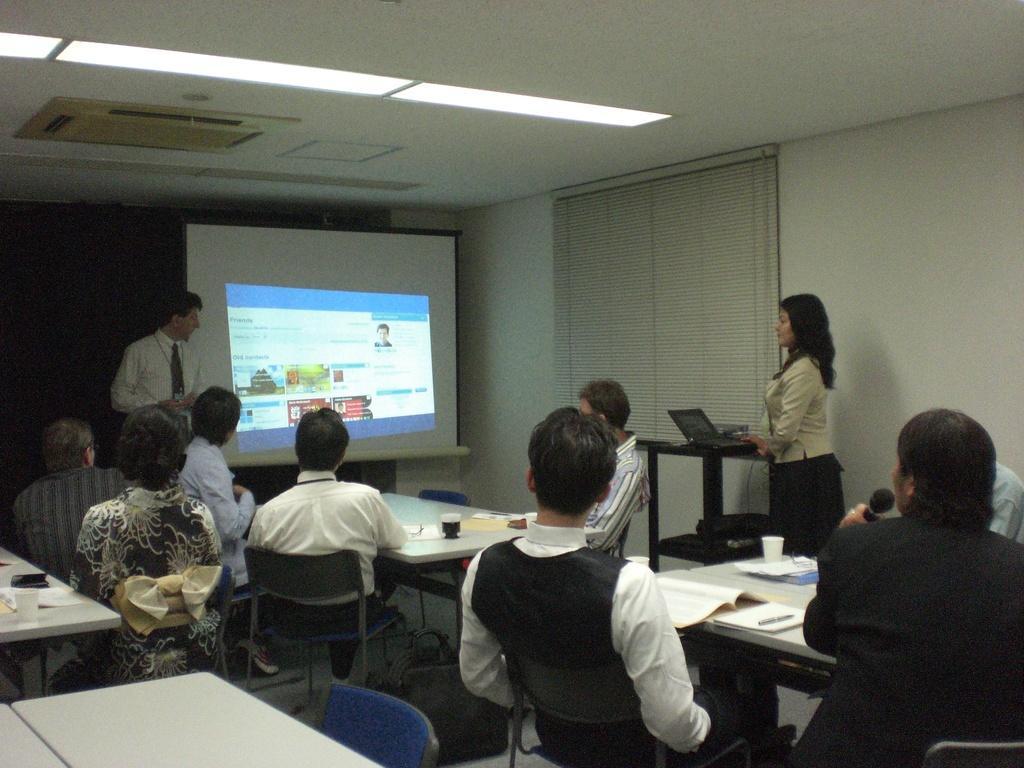Describe this image in one or two sentences. In this picture we can see some persons are sitting on the chairs. These are the tables. On the table there are books, and a cup. Here we can see two persons standing on the floor. This is laptop. Here we can see a screen and this is wall. And these are the lights. 